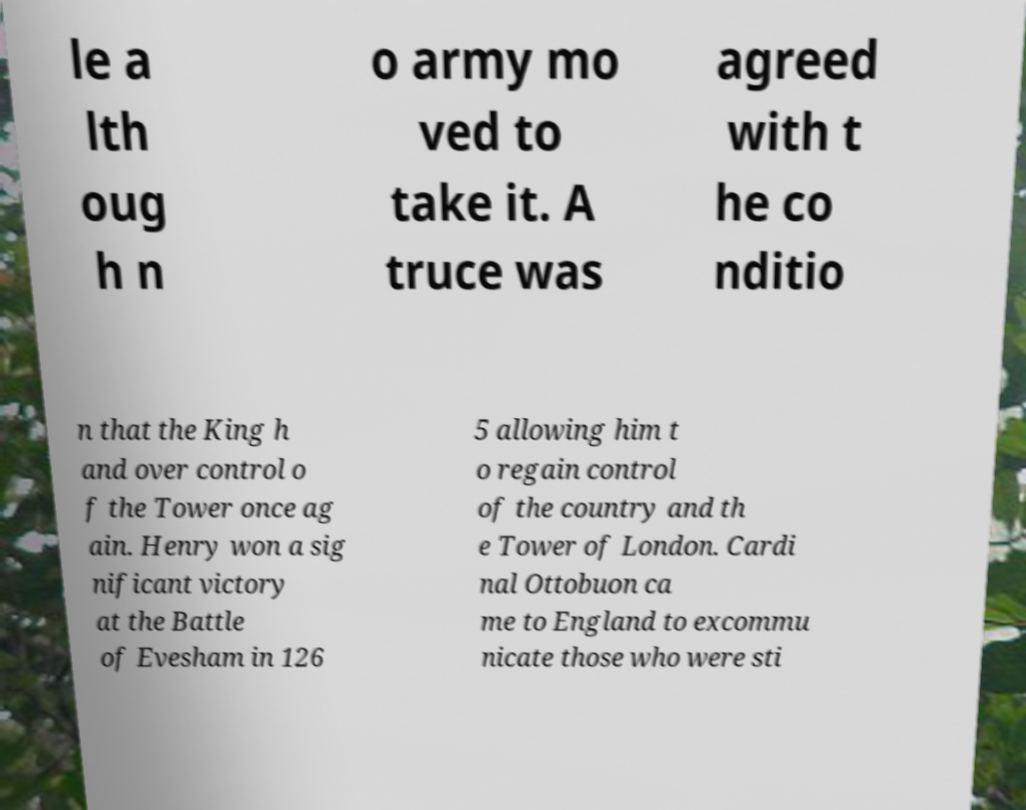Can you read and provide the text displayed in the image?This photo seems to have some interesting text. Can you extract and type it out for me? le a lth oug h n o army mo ved to take it. A truce was agreed with t he co nditio n that the King h and over control o f the Tower once ag ain. Henry won a sig nificant victory at the Battle of Evesham in 126 5 allowing him t o regain control of the country and th e Tower of London. Cardi nal Ottobuon ca me to England to excommu nicate those who were sti 